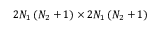Convert formula to latex. <formula><loc_0><loc_0><loc_500><loc_500>2 N _ { 1 } \left ( N _ { 2 } + 1 \right ) \times 2 N _ { 1 } \left ( N _ { 2 } + 1 \right )</formula> 